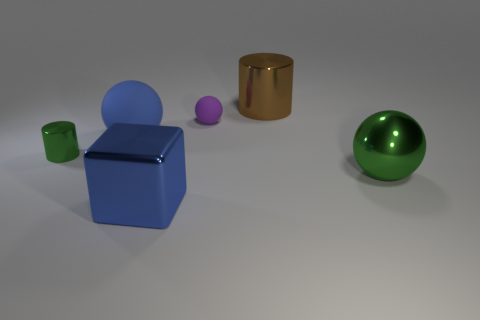There is a rubber object that is the same color as the shiny block; what is its shape?
Your response must be concise. Sphere. Is there a big sphere that has the same color as the tiny metallic object?
Your response must be concise. Yes. What is the size of the metal cylinder that is the same color as the big metal sphere?
Offer a terse response. Small. Is the material of the large thing that is on the left side of the big blue shiny cube the same as the brown object?
Keep it short and to the point. No. Do the small cylinder and the ball that is to the right of the small purple sphere have the same color?
Your answer should be compact. Yes. How many tiny purple objects are in front of the small green cylinder that is behind the blue metal block?
Offer a terse response. 0. What is the material of the big thing that is the same shape as the small metallic object?
Ensure brevity in your answer.  Metal. What number of gray objects are large metal spheres or matte blocks?
Keep it short and to the point. 0. Is there any other thing that has the same color as the big metallic block?
Offer a terse response. Yes. What color is the sphere in front of the cylinder that is left of the big blue ball?
Your answer should be very brief. Green. 